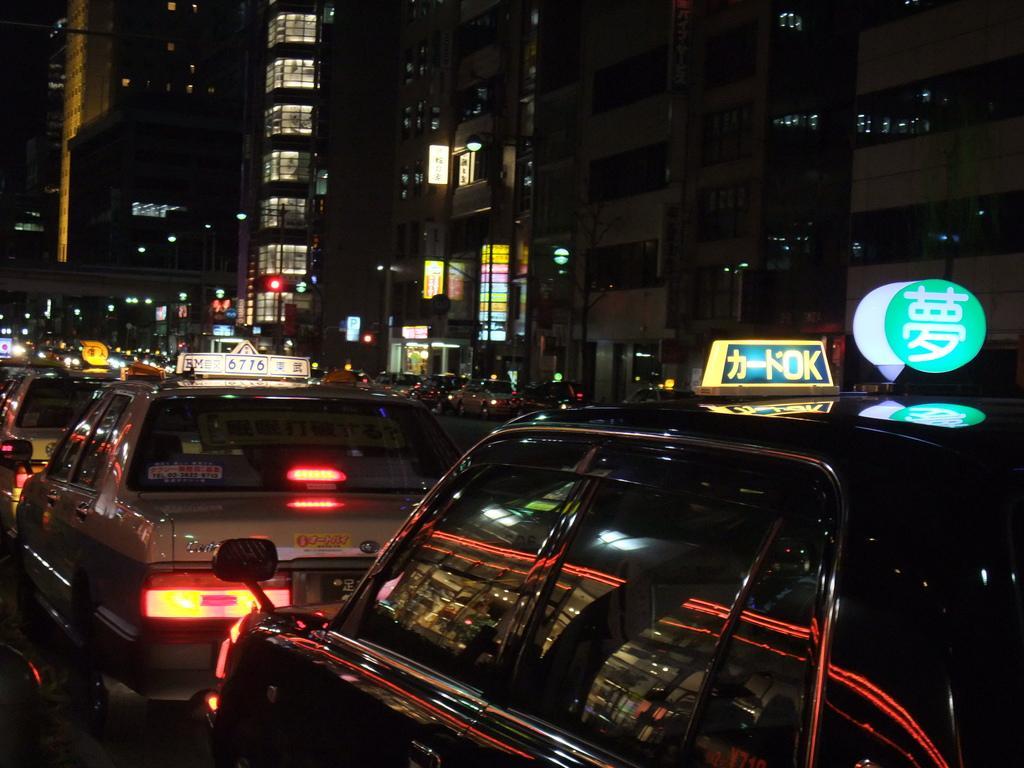How would you summarize this image in a sentence or two? In this picture I can see few cars in front and I see boards on them on which there is something written. In the background I see the buildings and I see few more cars and I see the lights. 